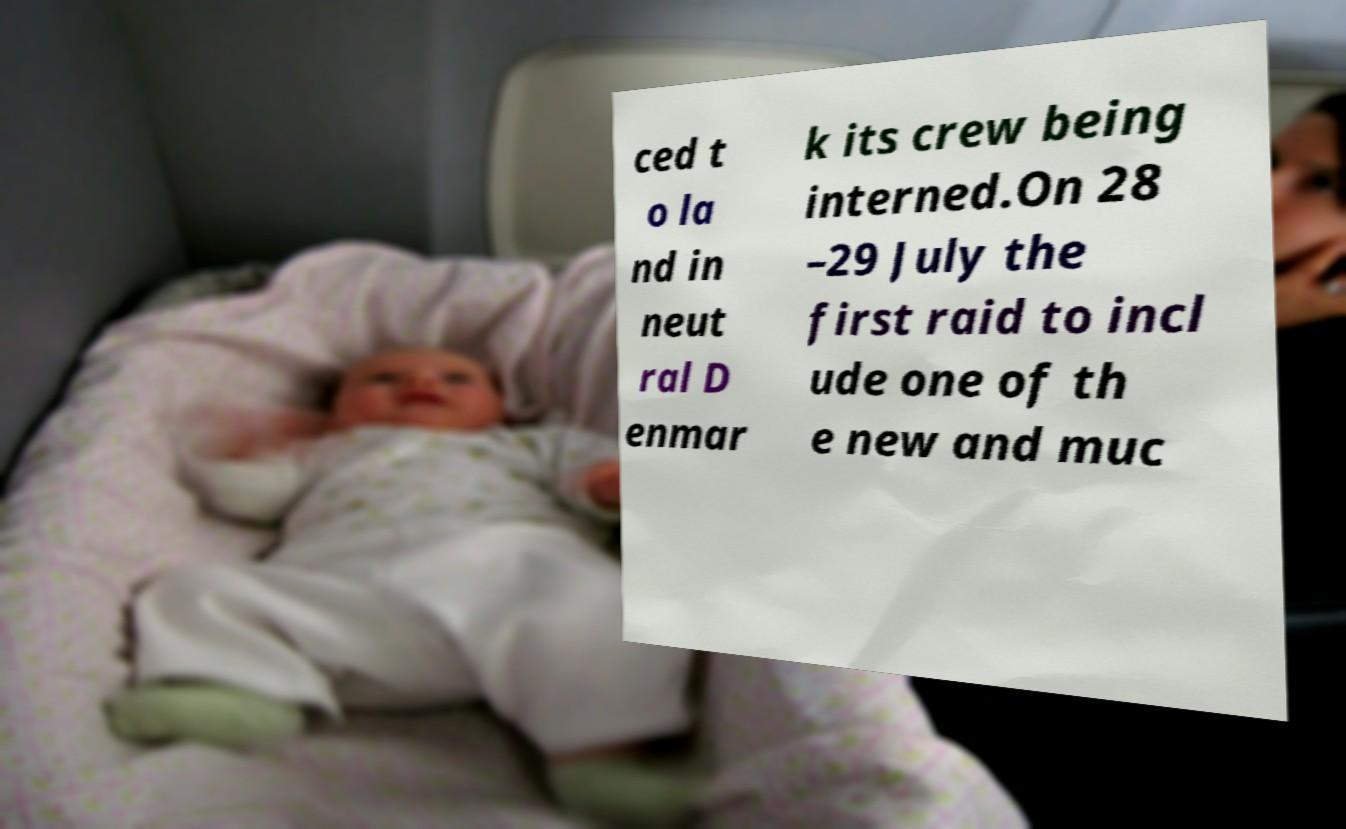Can you accurately transcribe the text from the provided image for me? ced t o la nd in neut ral D enmar k its crew being interned.On 28 –29 July the first raid to incl ude one of th e new and muc 